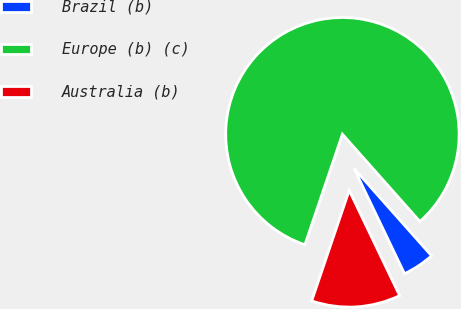Convert chart. <chart><loc_0><loc_0><loc_500><loc_500><pie_chart><fcel>Brazil (b)<fcel>Europe (b) (c)<fcel>Australia (b)<nl><fcel>4.44%<fcel>83.24%<fcel>12.32%<nl></chart> 